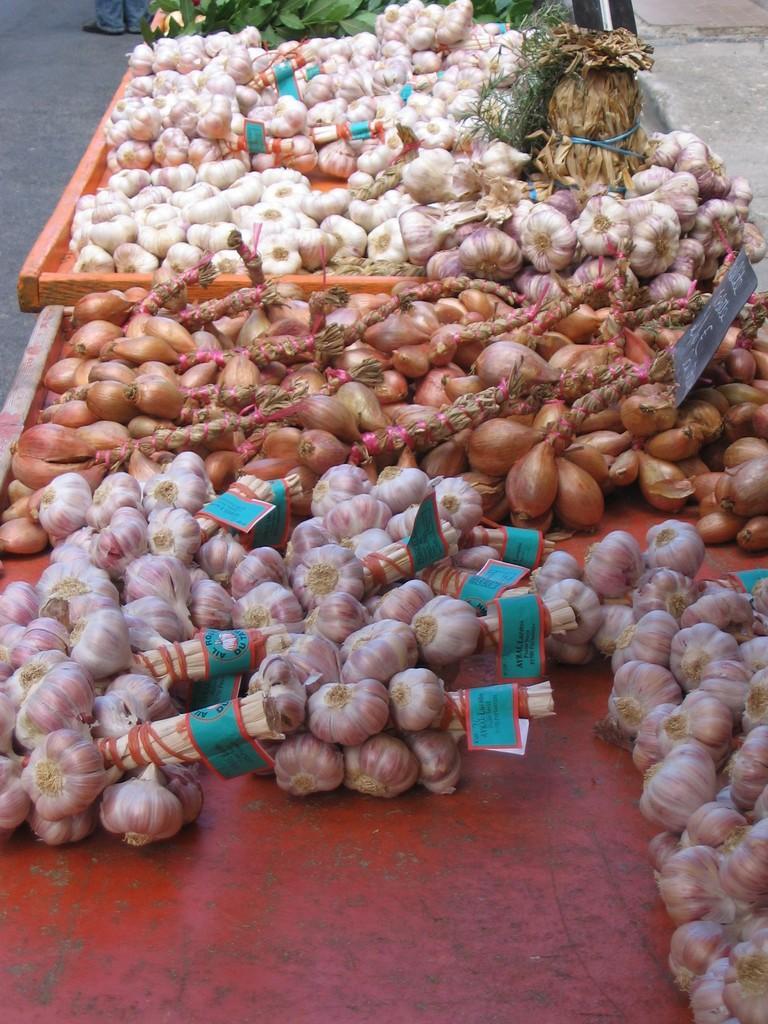Could you give a brief overview of what you see in this image? In this image I can see onions and garlic kept in two carts I can see a board with some text in onions. Onion and garlic are tied as a bunch and holding some labels. 